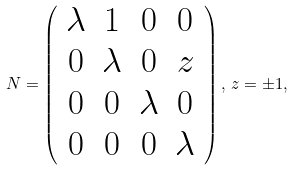<formula> <loc_0><loc_0><loc_500><loc_500>N = \left ( \begin{array} { c c c c } \lambda & 1 & 0 & 0 \\ 0 & \lambda & 0 & z \\ 0 & 0 & \lambda & 0 \\ 0 & 0 & 0 & \lambda \end{array} \right ) , \, z = \pm 1 ,</formula> 